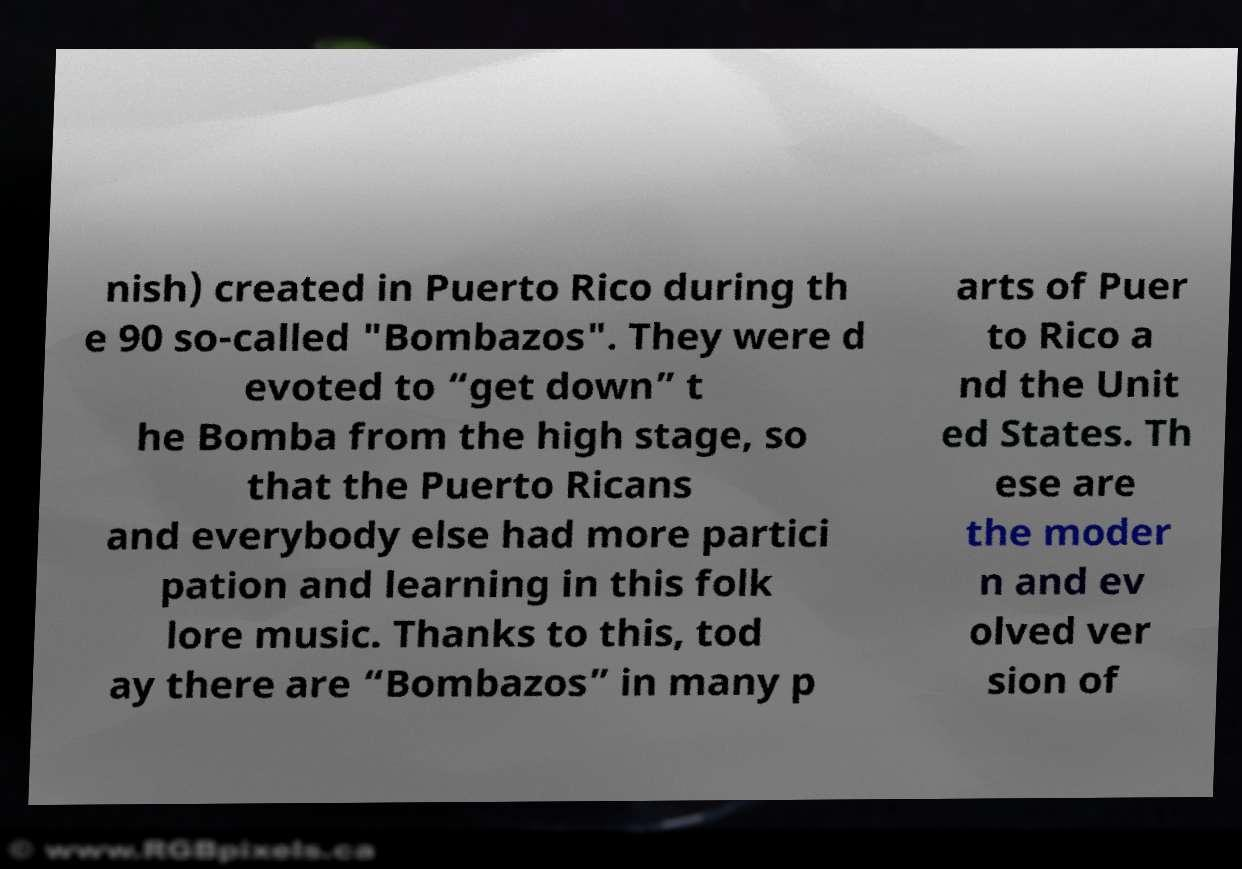What messages or text are displayed in this image? I need them in a readable, typed format. nish) created in Puerto Rico during th e 90 so-called "Bombazos". They were d evoted to “get down” t he Bomba from the high stage, so that the Puerto Ricans and everybody else had more partici pation and learning in this folk lore music. Thanks to this, tod ay there are “Bombazos” in many p arts of Puer to Rico a nd the Unit ed States. Th ese are the moder n and ev olved ver sion of 